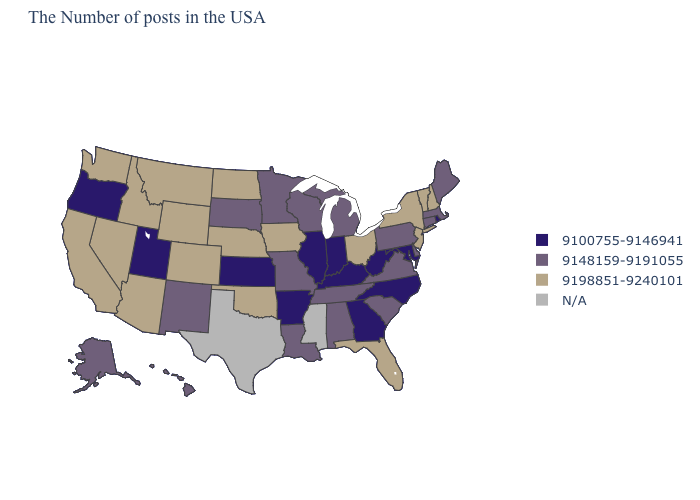What is the highest value in the South ?
Write a very short answer. 9198851-9240101. Which states have the lowest value in the West?
Concise answer only. Utah, Oregon. What is the value of South Dakota?
Write a very short answer. 9148159-9191055. Does Montana have the lowest value in the West?
Keep it brief. No. Does the map have missing data?
Keep it brief. Yes. What is the value of Tennessee?
Keep it brief. 9148159-9191055. Does the first symbol in the legend represent the smallest category?
Give a very brief answer. Yes. What is the value of New Mexico?
Quick response, please. 9148159-9191055. Among the states that border Pennsylvania , which have the lowest value?
Give a very brief answer. Maryland, West Virginia. Name the states that have a value in the range 9198851-9240101?
Short answer required. New Hampshire, Vermont, New York, New Jersey, Ohio, Florida, Iowa, Nebraska, Oklahoma, North Dakota, Wyoming, Colorado, Montana, Arizona, Idaho, Nevada, California, Washington. Which states have the lowest value in the USA?
Short answer required. Rhode Island, Maryland, North Carolina, West Virginia, Georgia, Kentucky, Indiana, Illinois, Arkansas, Kansas, Utah, Oregon. Does the first symbol in the legend represent the smallest category?
Write a very short answer. Yes. 